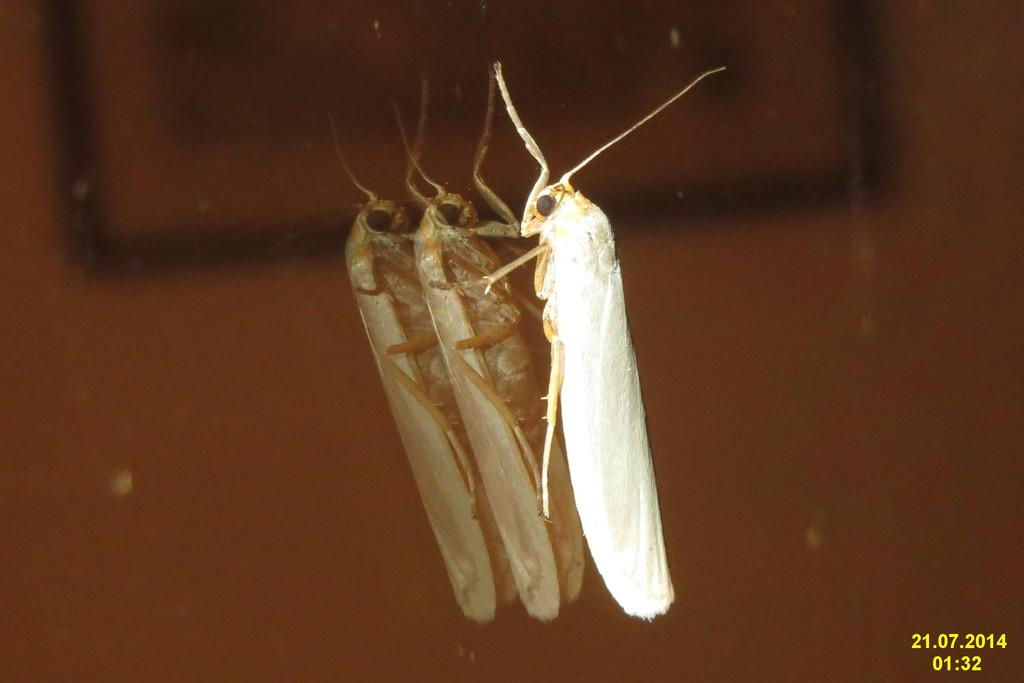What type of insect is in the image? There is a grasshopper in the image. Where is the grasshopper located? The grasshopper is on a mirror. What type of plantation is visible in the image? There is no plantation present in the image; it features a grasshopper on a mirror. How many beans can be seen in the image? There are no beans present in the image. 